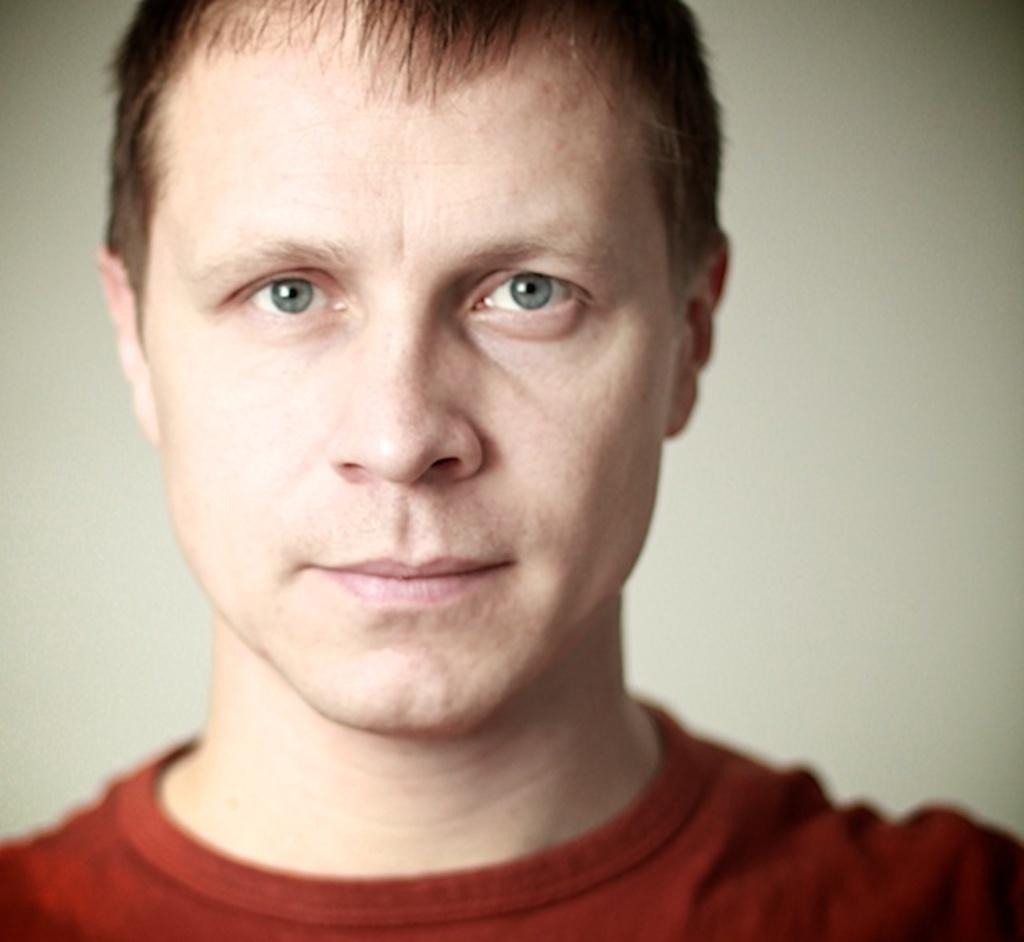What is the main subject of the image? There is a man in the image. What is the man wearing? The man is wearing a red t-shirt. What can be seen in the background of the image? There is a wall visible in the image. How many balloons are tied to the man's wrist in the image? There are no balloons present in the image. Can you see a squirrel climbing the wall in the image? There is no squirrel visible in the image. 